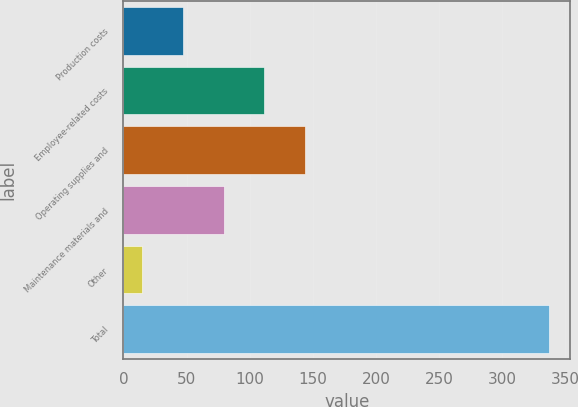<chart> <loc_0><loc_0><loc_500><loc_500><bar_chart><fcel>Production costs<fcel>Employee-related costs<fcel>Operating supplies and<fcel>Maintenance materials and<fcel>Other<fcel>Total<nl><fcel>47.2<fcel>111.6<fcel>143.8<fcel>79.4<fcel>15<fcel>337<nl></chart> 